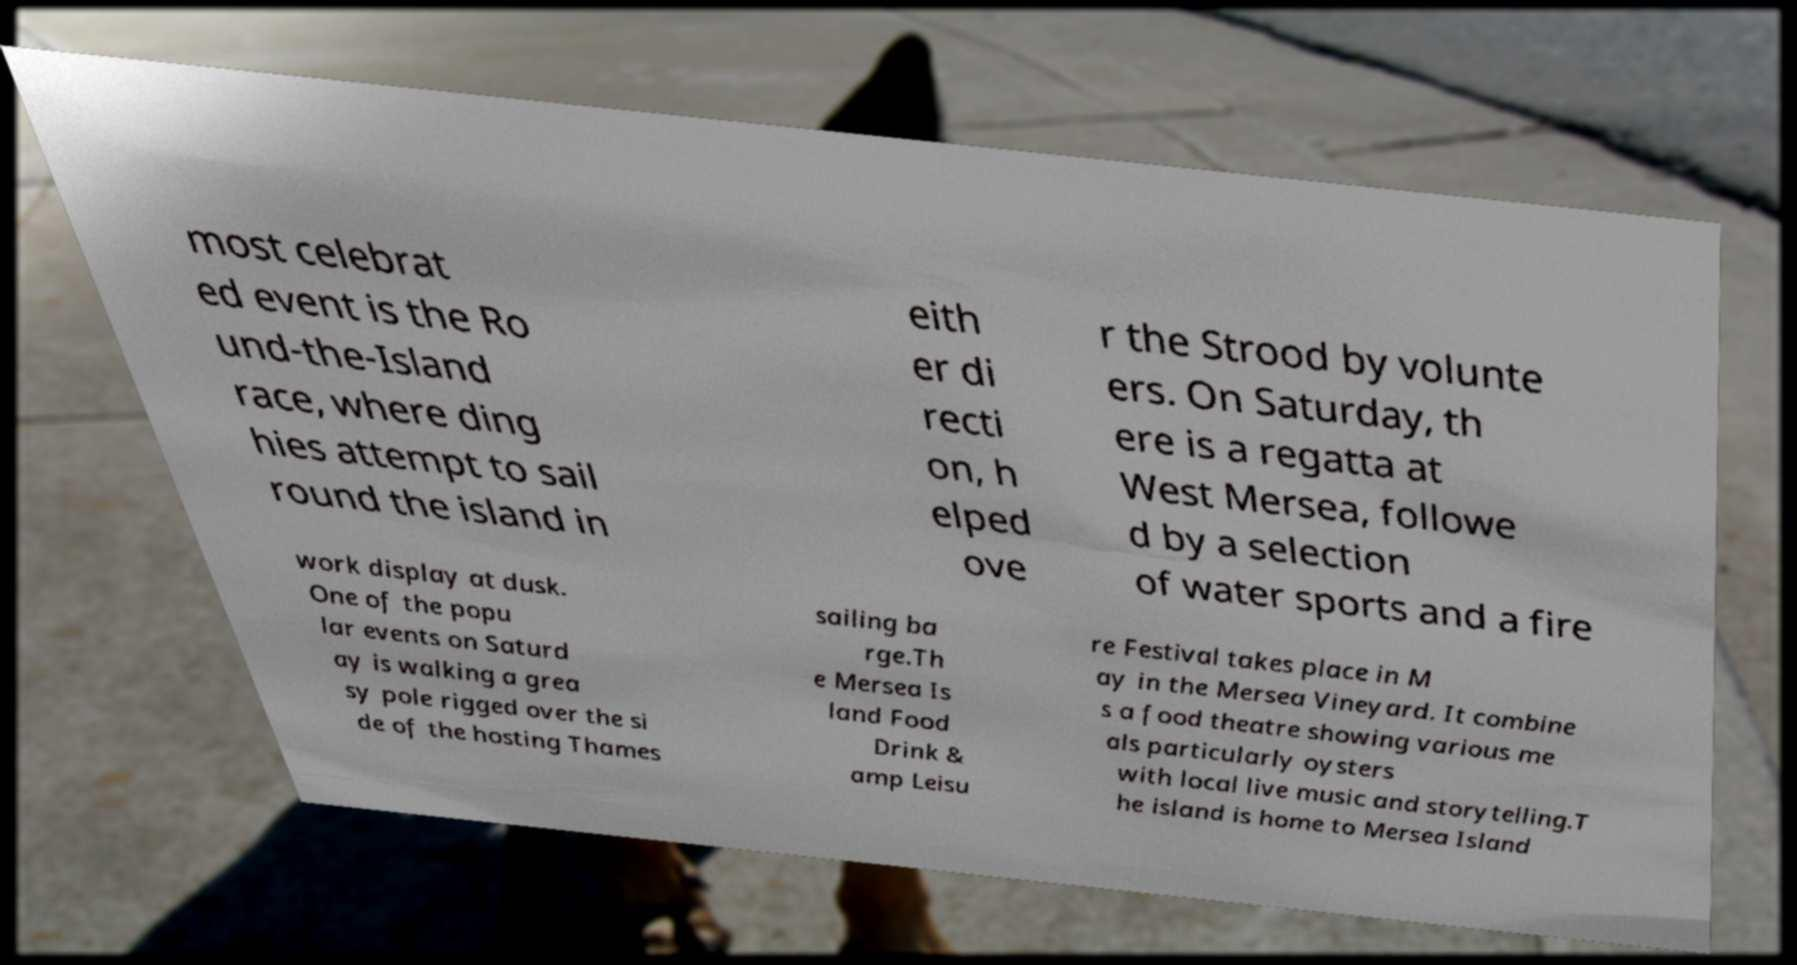Could you extract and type out the text from this image? most celebrat ed event is the Ro und-the-Island race, where ding hies attempt to sail round the island in eith er di recti on, h elped ove r the Strood by volunte ers. On Saturday, th ere is a regatta at West Mersea, followe d by a selection of water sports and a fire work display at dusk. One of the popu lar events on Saturd ay is walking a grea sy pole rigged over the si de of the hosting Thames sailing ba rge.Th e Mersea Is land Food Drink & amp Leisu re Festival takes place in M ay in the Mersea Vineyard. It combine s a food theatre showing various me als particularly oysters with local live music and storytelling.T he island is home to Mersea Island 